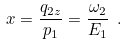Convert formula to latex. <formula><loc_0><loc_0><loc_500><loc_500>x = \frac { q _ { 2 z } } { p _ { 1 } } = \frac { \omega _ { 2 } } { E _ { 1 } } \ .</formula> 